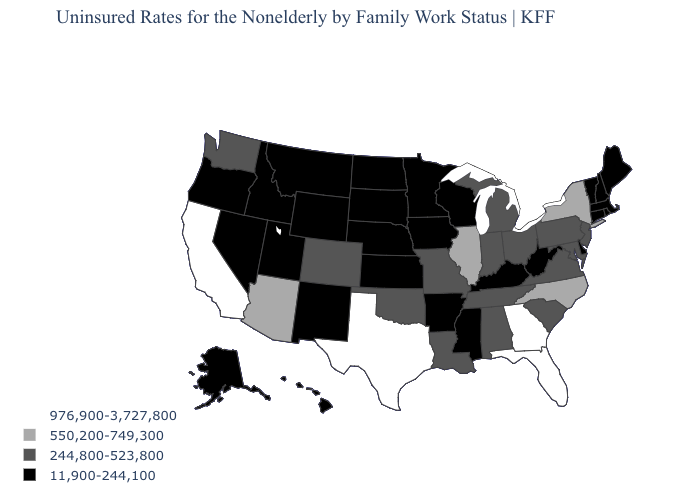What is the value of Wisconsin?
Answer briefly. 11,900-244,100. Name the states that have a value in the range 976,900-3,727,800?
Be succinct. California, Florida, Georgia, Texas. What is the highest value in the USA?
Concise answer only. 976,900-3,727,800. Name the states that have a value in the range 11,900-244,100?
Answer briefly. Alaska, Arkansas, Connecticut, Delaware, Hawaii, Idaho, Iowa, Kansas, Kentucky, Maine, Massachusetts, Minnesota, Mississippi, Montana, Nebraska, Nevada, New Hampshire, New Mexico, North Dakota, Oregon, Rhode Island, South Dakota, Utah, Vermont, West Virginia, Wisconsin, Wyoming. What is the highest value in the USA?
Write a very short answer. 976,900-3,727,800. Does Connecticut have the lowest value in the Northeast?
Write a very short answer. Yes. Which states have the highest value in the USA?
Answer briefly. California, Florida, Georgia, Texas. What is the highest value in the West ?
Short answer required. 976,900-3,727,800. What is the value of Mississippi?
Write a very short answer. 11,900-244,100. What is the value of Maryland?
Quick response, please. 244,800-523,800. Which states hav the highest value in the MidWest?
Write a very short answer. Illinois. What is the value of South Carolina?
Short answer required. 244,800-523,800. Which states hav the highest value in the West?
Keep it brief. California. Name the states that have a value in the range 244,800-523,800?
Give a very brief answer. Alabama, Colorado, Indiana, Louisiana, Maryland, Michigan, Missouri, New Jersey, Ohio, Oklahoma, Pennsylvania, South Carolina, Tennessee, Virginia, Washington. 